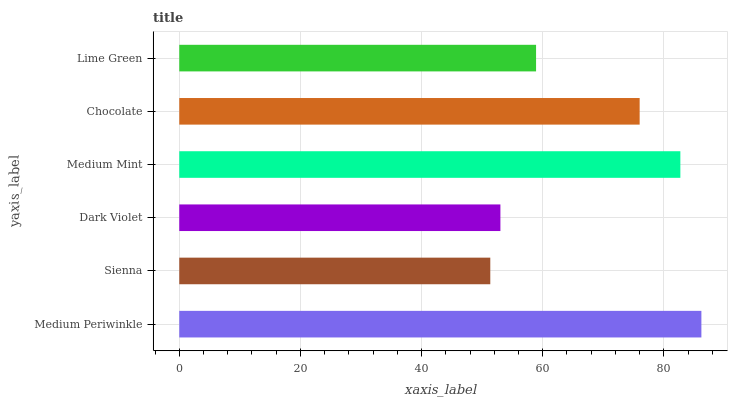Is Sienna the minimum?
Answer yes or no. Yes. Is Medium Periwinkle the maximum?
Answer yes or no. Yes. Is Dark Violet the minimum?
Answer yes or no. No. Is Dark Violet the maximum?
Answer yes or no. No. Is Dark Violet greater than Sienna?
Answer yes or no. Yes. Is Sienna less than Dark Violet?
Answer yes or no. Yes. Is Sienna greater than Dark Violet?
Answer yes or no. No. Is Dark Violet less than Sienna?
Answer yes or no. No. Is Chocolate the high median?
Answer yes or no. Yes. Is Lime Green the low median?
Answer yes or no. Yes. Is Sienna the high median?
Answer yes or no. No. Is Medium Periwinkle the low median?
Answer yes or no. No. 